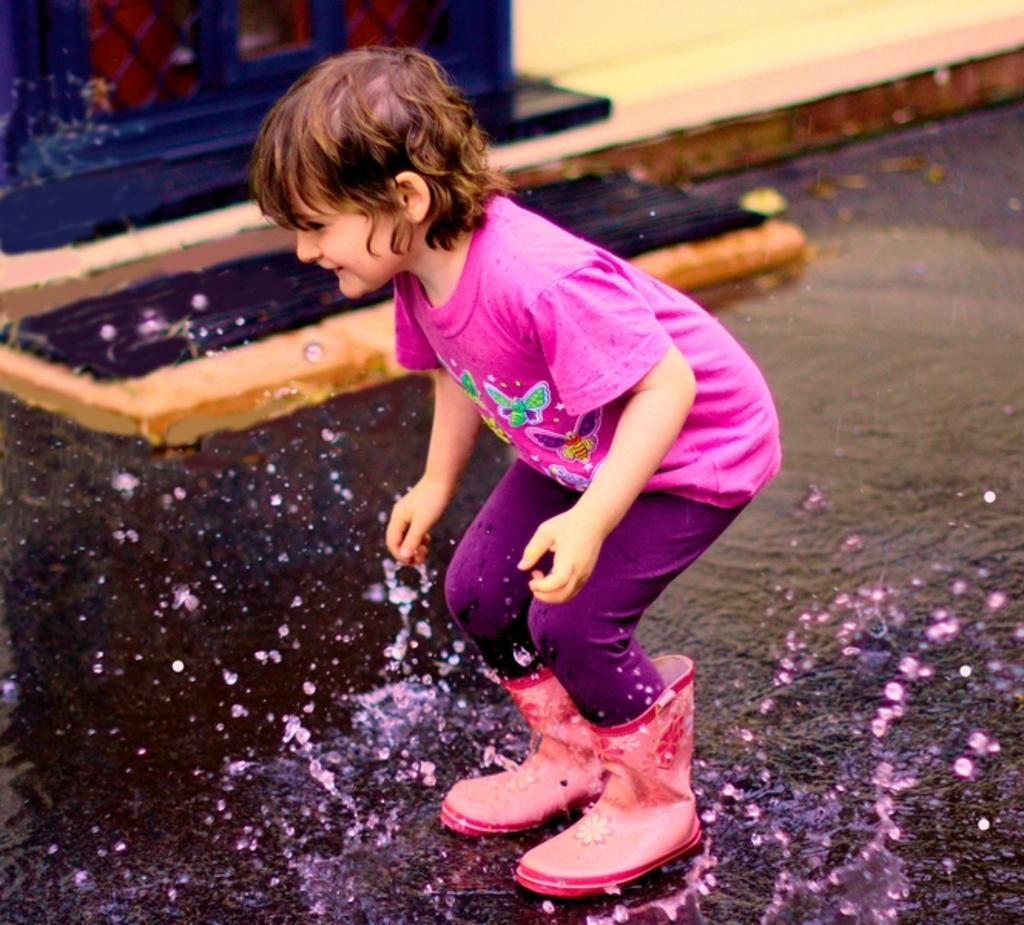What is present in the image? There is a person in the image. What is the person wearing? The person is wearing a pink t-shirt. What can be seen in the background of the image? There is water visible in the image. What is the primary architectural feature in the image? There is a wall in the image. What word is written on the parcel in the image? There is no parcel present in the image, so it is not possible to determine what word might be written on it. 